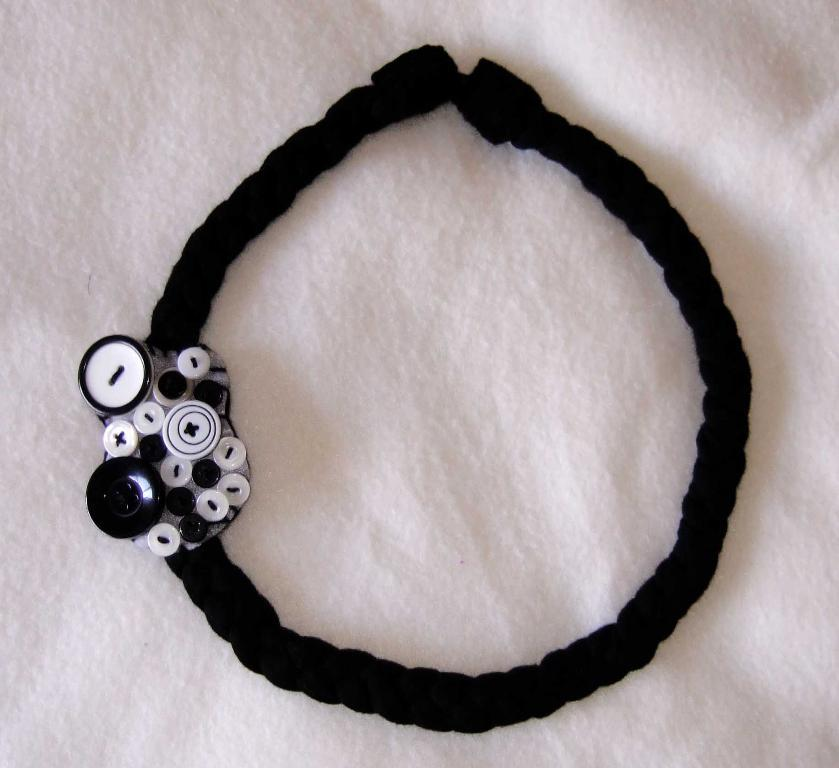What object is in the image that is used for holding hair? There is a hair band in the image. Where is the hair band placed in the image? The hair band is on a white cloth. What can be seen on the left side of the image? There are bottoms stacked one above the other on the left side of the image. What type of land can be seen in the image? There is no land visible in the image; it features a hair band on a white cloth and stacked bottoms. Are there any fowl present in the image? There are no fowl present in the image. 